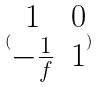Convert formula to latex. <formula><loc_0><loc_0><loc_500><loc_500>( \begin{matrix} 1 & 0 \\ - \frac { 1 } { f } & 1 \end{matrix} )</formula> 